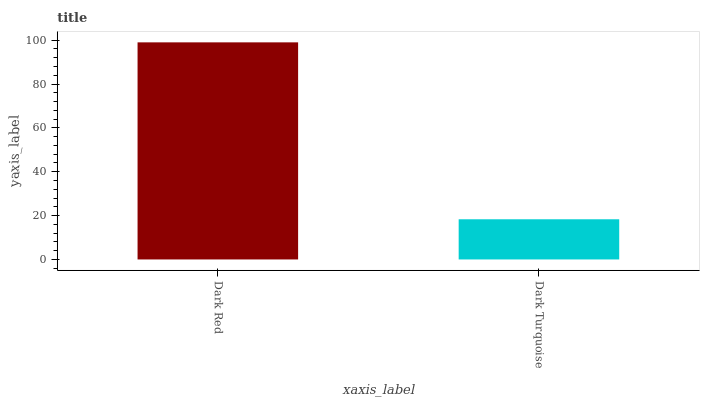Is Dark Turquoise the minimum?
Answer yes or no. Yes. Is Dark Red the maximum?
Answer yes or no. Yes. Is Dark Turquoise the maximum?
Answer yes or no. No. Is Dark Red greater than Dark Turquoise?
Answer yes or no. Yes. Is Dark Turquoise less than Dark Red?
Answer yes or no. Yes. Is Dark Turquoise greater than Dark Red?
Answer yes or no. No. Is Dark Red less than Dark Turquoise?
Answer yes or no. No. Is Dark Red the high median?
Answer yes or no. Yes. Is Dark Turquoise the low median?
Answer yes or no. Yes. Is Dark Turquoise the high median?
Answer yes or no. No. Is Dark Red the low median?
Answer yes or no. No. 